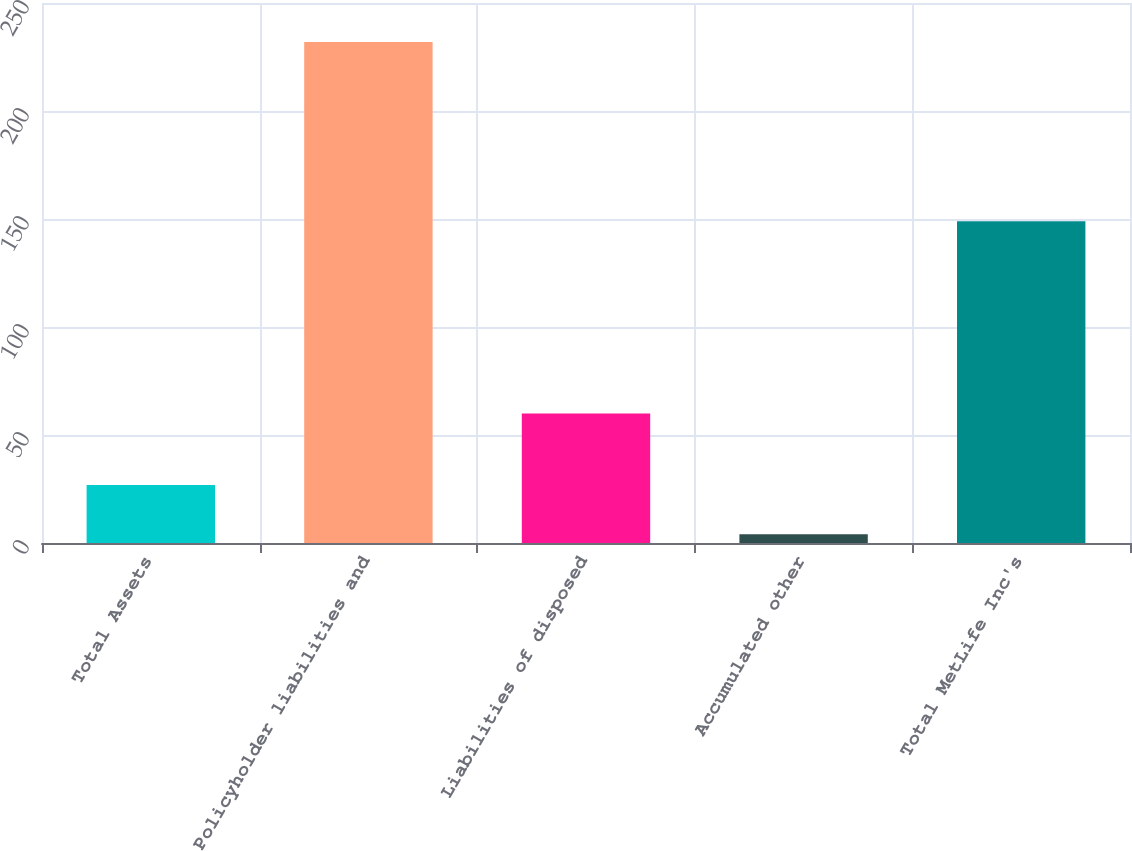Convert chart to OTSL. <chart><loc_0><loc_0><loc_500><loc_500><bar_chart><fcel>Total Assets<fcel>Policyholder liabilities and<fcel>Liabilities of disposed<fcel>Accumulated other<fcel>Total MetLife Inc's<nl><fcel>26.8<fcel>232<fcel>60<fcel>4<fcel>149<nl></chart> 